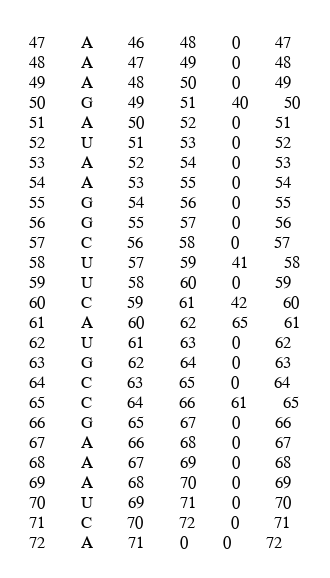Convert code to text. <code><loc_0><loc_0><loc_500><loc_500><_XML_>47		A		46		48		0		47
48		A		47		49		0		48
49		A		48		50		0		49
50		G		49		51		40		50
51		A		50		52		0		51
52		U		51		53		0		52
53		A		52		54		0		53
54		A		53		55		0		54
55		G		54		56		0		55
56		G		55		57		0		56
57		C		56		58		0		57
58		U		57		59		41		58
59		U		58		60		0		59
60		C		59		61		42		60
61		A		60		62		65		61
62		U		61		63		0		62
63		G		62		64		0		63
64		C		63		65		0		64
65		C		64		66		61		65
66		G		65		67		0		66
67		A		66		68		0		67
68		A		67		69		0		68
69		A		68		70		0		69
70		U		69		71		0		70
71		C		70		72		0		71
72		A		71		0		0		72
</code> 